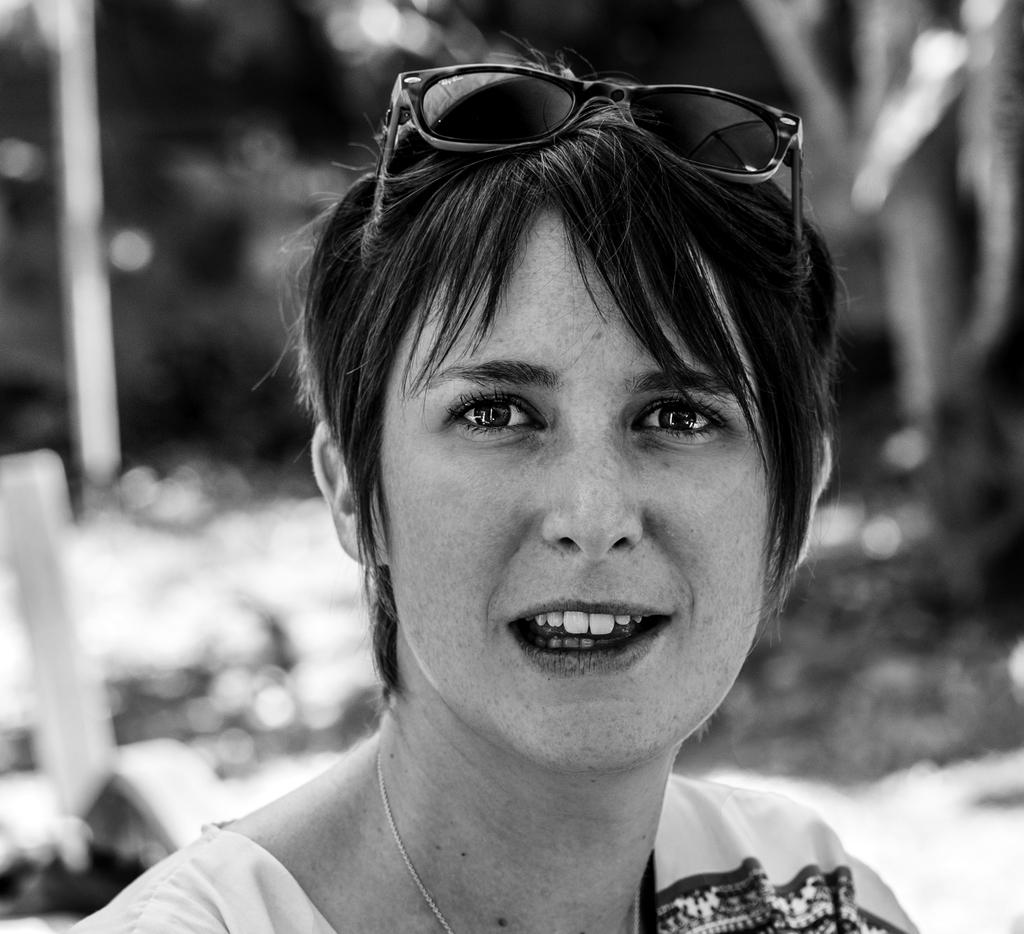What is the color scheme of the image? The image is black and white. Who is present in the image? There is a woman in the image. What is the woman wearing on her head? The woman is wearing goggles on her head. Can you describe the background of the image? The background of the image is blurry. What type of bread can be seen in the woman's hand in the image? There is no bread present in the image; the woman is not holding anything in her hand. 